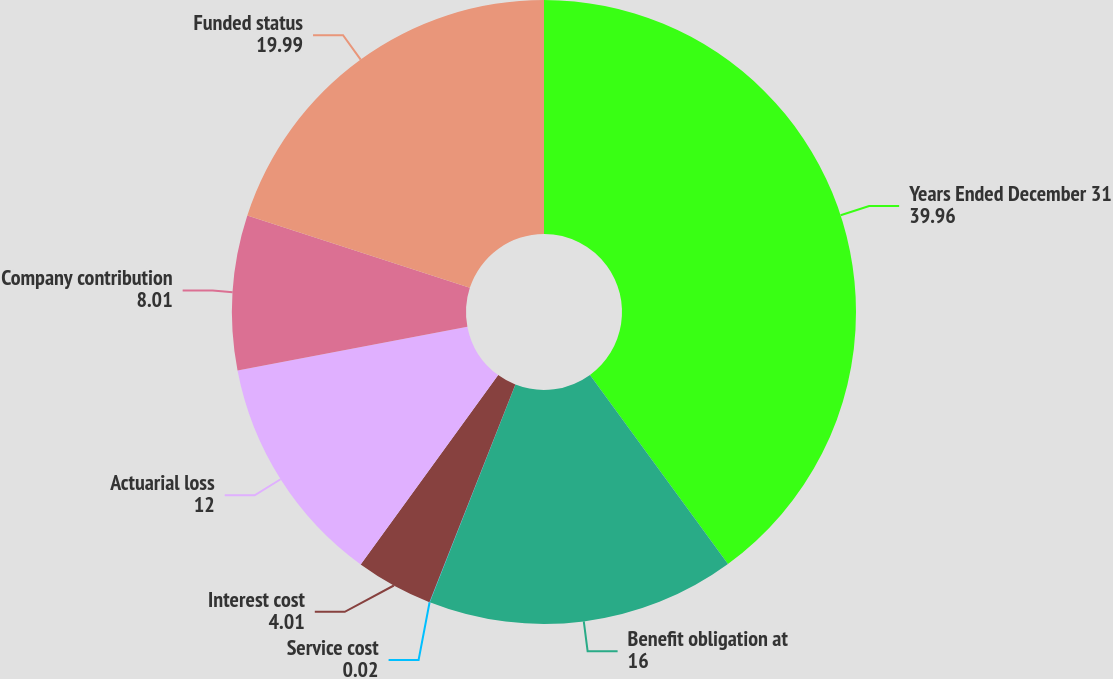Convert chart to OTSL. <chart><loc_0><loc_0><loc_500><loc_500><pie_chart><fcel>Years Ended December 31<fcel>Benefit obligation at<fcel>Service cost<fcel>Interest cost<fcel>Actuarial loss<fcel>Company contribution<fcel>Funded status<nl><fcel>39.96%<fcel>16.0%<fcel>0.02%<fcel>4.01%<fcel>12.0%<fcel>8.01%<fcel>19.99%<nl></chart> 